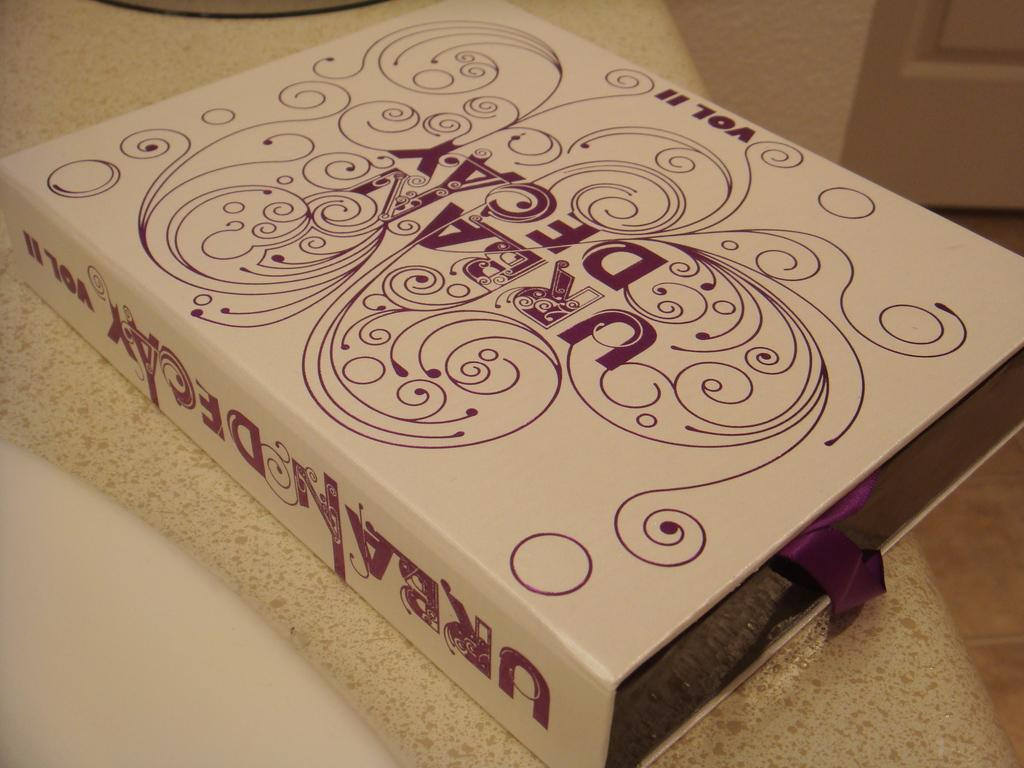Provide a one-sentence caption for the provided image. The box of Urban Decay volume II makeup sits on the bathroom counter top. 